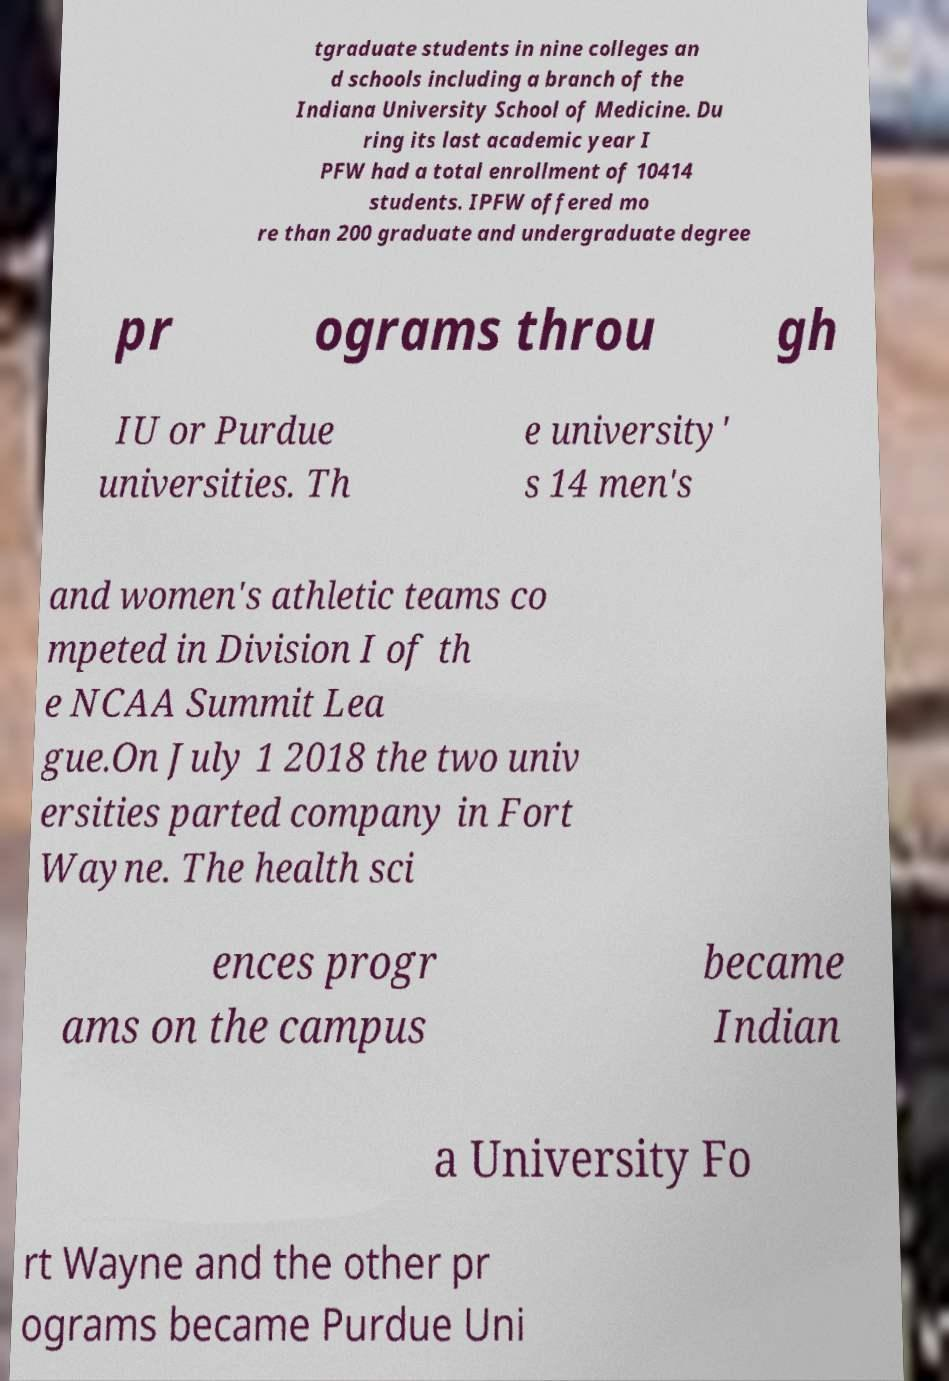Can you read and provide the text displayed in the image?This photo seems to have some interesting text. Can you extract and type it out for me? tgraduate students in nine colleges an d schools including a branch of the Indiana University School of Medicine. Du ring its last academic year I PFW had a total enrollment of 10414 students. IPFW offered mo re than 200 graduate and undergraduate degree pr ograms throu gh IU or Purdue universities. Th e university' s 14 men's and women's athletic teams co mpeted in Division I of th e NCAA Summit Lea gue.On July 1 2018 the two univ ersities parted company in Fort Wayne. The health sci ences progr ams on the campus became Indian a University Fo rt Wayne and the other pr ograms became Purdue Uni 